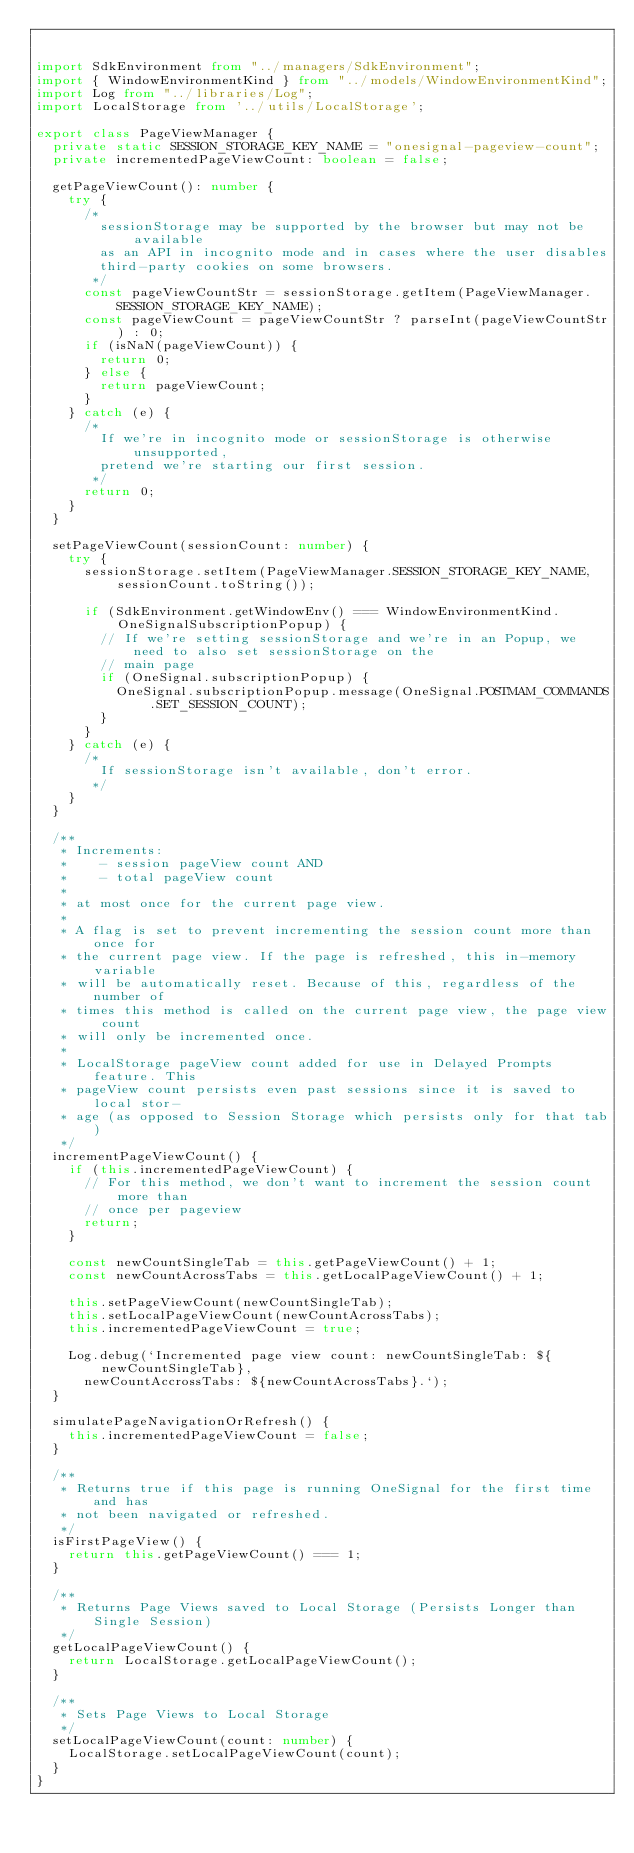Convert code to text. <code><loc_0><loc_0><loc_500><loc_500><_TypeScript_>

import SdkEnvironment from "../managers/SdkEnvironment";
import { WindowEnvironmentKind } from "../models/WindowEnvironmentKind";
import Log from "../libraries/Log";
import LocalStorage from '../utils/LocalStorage';

export class PageViewManager {
  private static SESSION_STORAGE_KEY_NAME = "onesignal-pageview-count";
  private incrementedPageViewCount: boolean = false;

  getPageViewCount(): number {
    try {
      /*
        sessionStorage may be supported by the browser but may not be available
        as an API in incognito mode and in cases where the user disables
        third-party cookies on some browsers.
       */
      const pageViewCountStr = sessionStorage.getItem(PageViewManager.SESSION_STORAGE_KEY_NAME);
      const pageViewCount = pageViewCountStr ? parseInt(pageViewCountStr) : 0;
      if (isNaN(pageViewCount)) {
        return 0;
      } else {
        return pageViewCount;
      }
    } catch (e) {
      /*
        If we're in incognito mode or sessionStorage is otherwise unsupported,
        pretend we're starting our first session.
       */
      return 0;
    }
  }

  setPageViewCount(sessionCount: number) {
    try {
      sessionStorage.setItem(PageViewManager.SESSION_STORAGE_KEY_NAME, sessionCount.toString());

      if (SdkEnvironment.getWindowEnv() === WindowEnvironmentKind.OneSignalSubscriptionPopup) {
        // If we're setting sessionStorage and we're in an Popup, we need to also set sessionStorage on the
        // main page
        if (OneSignal.subscriptionPopup) {
          OneSignal.subscriptionPopup.message(OneSignal.POSTMAM_COMMANDS.SET_SESSION_COUNT);
        }
      }
    } catch (e) {
      /*
        If sessionStorage isn't available, don't error.
       */
    }
  }

  /**
   * Increments:
   *    - session pageView count AND 
   *    - total pageView count 
   * 
   * at most once for the current page view.
   *
   * A flag is set to prevent incrementing the session count more than once for
   * the current page view. If the page is refreshed, this in-memory variable
   * will be automatically reset. Because of this, regardless of the number of
   * times this method is called on the current page view, the page view count
   * will only be incremented once.
   * 
   * LocalStorage pageView count added for use in Delayed Prompts feature. This
   * pageView count persists even past sessions since it is saved to local stor-
   * age (as opposed to Session Storage which persists only for that tab)
   */
  incrementPageViewCount() {
    if (this.incrementedPageViewCount) {
      // For this method, we don't want to increment the session count more than
      // once per pageview
      return;
    }

    const newCountSingleTab = this.getPageViewCount() + 1;
    const newCountAcrossTabs = this.getLocalPageViewCount() + 1;

    this.setPageViewCount(newCountSingleTab);
    this.setLocalPageViewCount(newCountAcrossTabs);
    this.incrementedPageViewCount = true;

    Log.debug(`Incremented page view count: newCountSingleTab: ${newCountSingleTab},
      newCountAccrossTabs: ${newCountAcrossTabs}.`);
  }

  simulatePageNavigationOrRefresh() {
    this.incrementedPageViewCount = false;
  }

  /**
   * Returns true if this page is running OneSignal for the first time and has
   * not been navigated or refreshed.
   */
  isFirstPageView() {
    return this.getPageViewCount() === 1;
  }

  /**
   * Returns Page Views saved to Local Storage (Persists Longer than Single Session)
   */
  getLocalPageViewCount() {
    return LocalStorage.getLocalPageViewCount();
  }

  /**
   * Sets Page Views to Local Storage 
   */
  setLocalPageViewCount(count: number) {
    LocalStorage.setLocalPageViewCount(count);
  }
}
</code> 